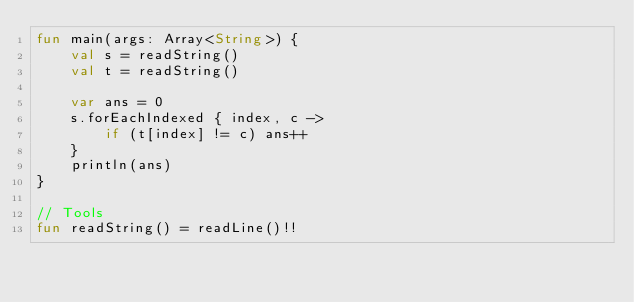<code> <loc_0><loc_0><loc_500><loc_500><_Kotlin_>fun main(args: Array<String>) {
    val s = readString()
    val t = readString()

    var ans = 0
    s.forEachIndexed { index, c ->
        if (t[index] != c) ans++
    }
    println(ans)
}

// Tools
fun readString() = readLine()!!</code> 